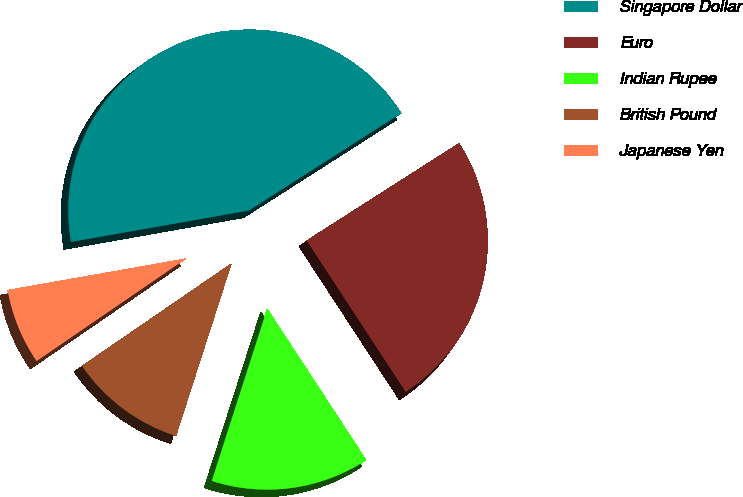<chart> <loc_0><loc_0><loc_500><loc_500><pie_chart><fcel>Singapore Dollar<fcel>Euro<fcel>Indian Rupee<fcel>British Pound<fcel>Japanese Yen<nl><fcel>43.73%<fcel>24.83%<fcel>14.17%<fcel>10.48%<fcel>6.78%<nl></chart> 